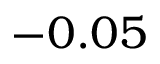Convert formula to latex. <formula><loc_0><loc_0><loc_500><loc_500>- 0 . 0 5</formula> 